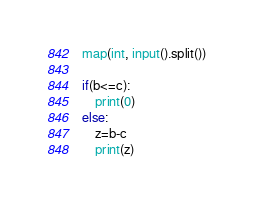Convert code to text. <code><loc_0><loc_0><loc_500><loc_500><_Python_>map(int, input().split())

if(b<=c):
    print(0)
else:
    z=b-c
    print(z)

</code> 